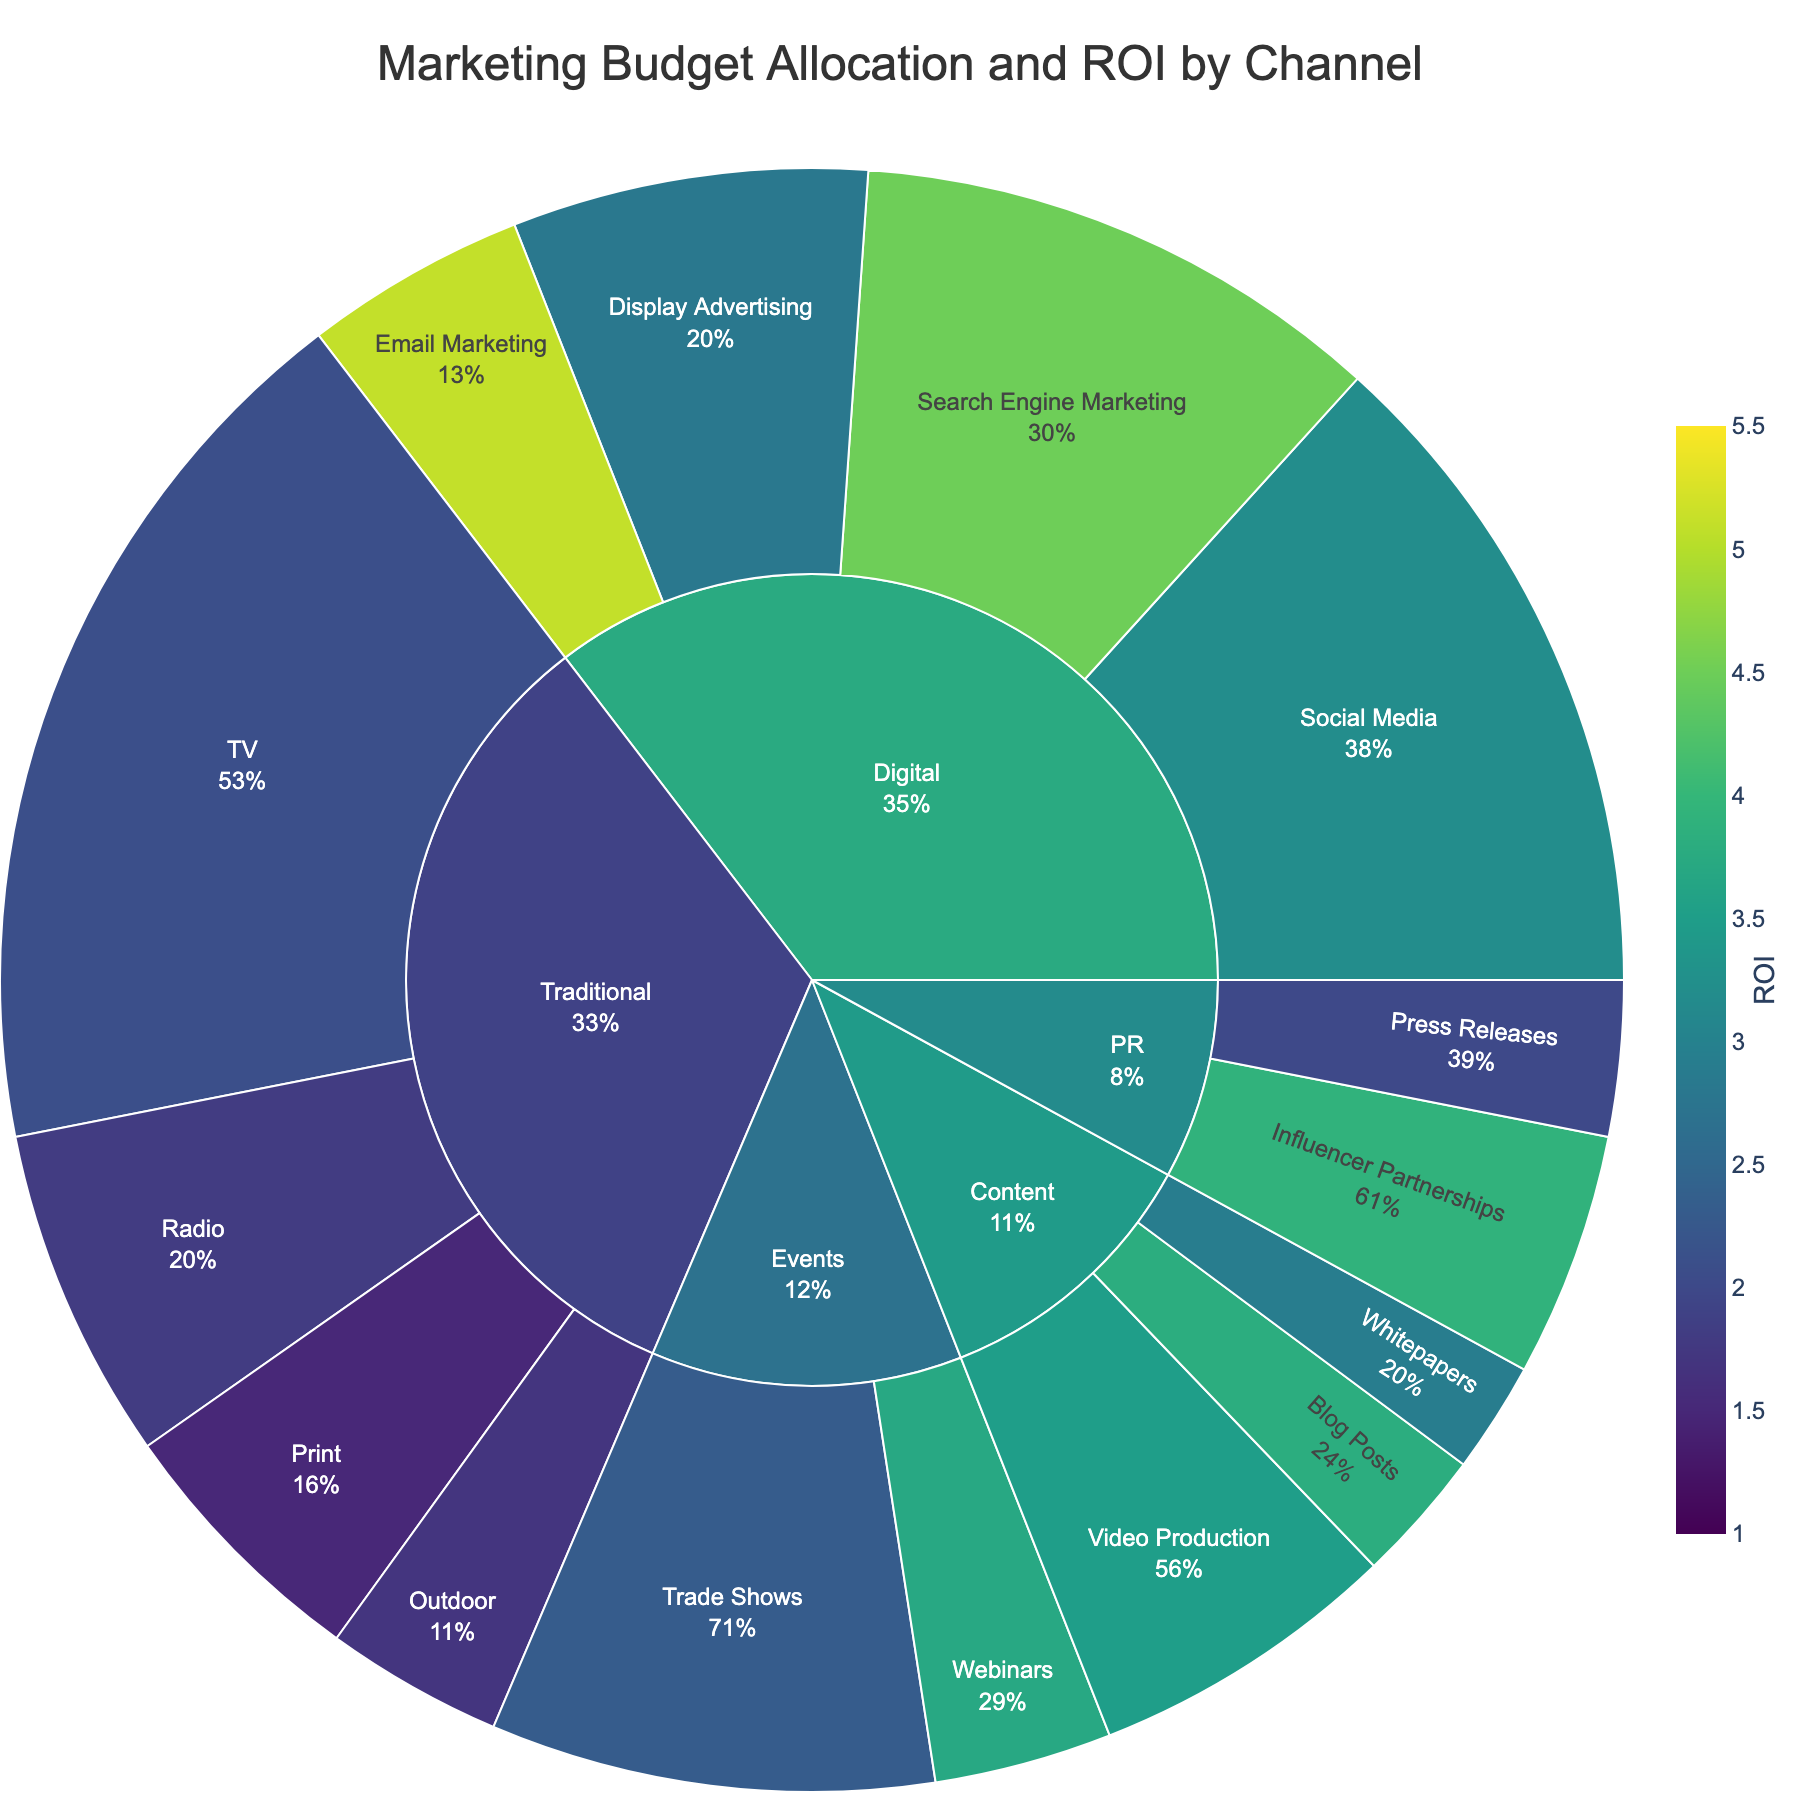What is the total budget allocated to Digital channels? To find the total budget for Digital channels, sum up the budgets of its subchannels: Social Media ($150,000), Search Engine Marketing ($120,000), Display Advertising ($80,000), and Email Marketing ($50,000). Total = 150000 + 120000 + 80000 + 50000 = 400000.
Answer: $400,000 Which marketing channel has the highest ROI? Refer to the colors representing ROI within each channel. Email Marketing in the Digital channel has the highest ROI of 5.1.
Answer: Email Marketing How does the budget allocation for Traditional channels compare to Digital channels? Sum the budgets for Traditional subchannels: TV ($200,000), Radio ($75,000), Print ($60,000), Outdoor ($40,000). Total = 200000 + 75000 + 60000 + 40000 = 375000. Compare this with the total budget for Digital channels ($400,000).
Answer: Digital has a higher budget What is the ROI of Webinars compared to Trade Shows within Events? Look at the ROI values for Webinars and Trade Shows in the Events channel. Webinars have an ROI of 3.7, and Trade Shows have an ROI of 2.3. Compare 3.7 and 2.3.
Answer: Webinars have a higher ROI What percentage of the total budget is allocated to Social Media? The budget for Social Media is $150,000. To find the percentage of the total budget, use (150000 / Total Budget) * 100. The total budget is calculated by summing all subchannels: $1,215,000. So, (150000 / 1215000) * 100 ≈ 12.3%.
Answer: 12.3% How does the total budget for PR channels compare with Content channels? Sum the budgets for PR subchannels: Press Releases ($35,000) and Influencer Partnerships ($55,000). Total = 35000 + 55000 = 90000. Sum the budgets for Content subchannels: Blog Posts ($30,000), Whitepapers ($25,000), Video Production ($70,000). Total = 30000 + 25000 + 70000 = 125000. Compare the totals.
Answer: Content has a higher budget Which subchannel within Digital has the lowest ROI? Look at the ROI values for subchannels within Digital: Social Media (3.2), Search Engine Marketing (4.5), Display Advertising (2.8), Email Marketing (5.1). Display Advertising has the lowest ROI.
Answer: Display Advertising What's the combined budget for channels with an ROI greater than 3? Identify subchannels with ROI greater than 3: Social Media ($150,000), Search Engine Marketing ($120,000), Email Marketing ($50,000), Blog Posts ($30,000), Video Production ($70,000), Webinars ($40,000), Influencer Partnerships ($55,000). Sum the budgets: 150000 + 120000 + 50000 + 30000 + 70000 + 40000 + 55000 = 515000.
Answer: $515,000 How does the ROI of TV compare to that of Radio? Refer to the ROI values for TV ($200,000, 2.1) and Radio ($75,000, 1.8). Compare 2.1 and 1.8.
Answer: TV has a higher ROI What is the average ROI of Digital subchannels? Calculate the average ROI of Digital subchannels: (3.2 + 4.5 + 2.8 + 5.1) / 4 = 15.6 / 4 = 3.9.
Answer: 3.9 